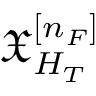<formula> <loc_0><loc_0><loc_500><loc_500>\mathfrak { X } _ { H _ { T } } ^ { [ n _ { F } ] }</formula> 